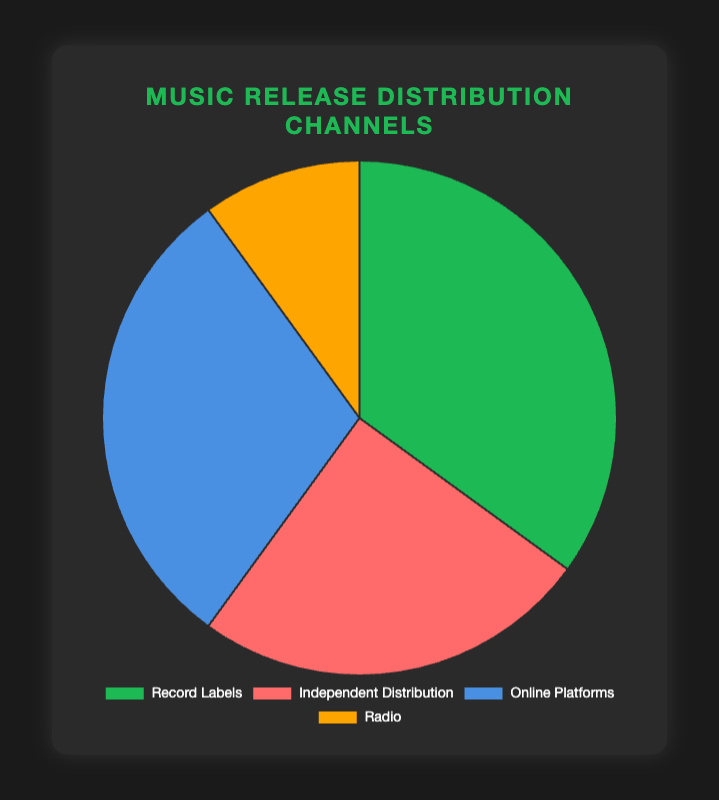Which distribution channel has the largest share of music releases? The pie chart shows the distribution channels for music releases and their corresponding percentages. The largest slice represents Record Labels with 35%.
Answer: Record Labels What is the combined percentage of music releases through Record Labels and Online Platforms? In the pie chart, Record Labels have 35% and Online Platforms have 30%. Adding these percentages together: 35% + 30% = 65%.
Answer: 65% How does the share of Independent Distribution compare to that of Radio? The pie chart shows Independent Distribution at 25% and Radio at 10%. Independent Distribution is greater by 15% (25% - 10%).
Answer: Independent Distribution is 15% greater What is the difference between the highest and lowest percentage distribution channels? The chart shows the highest percentage is for Record Labels (35%) and the lowest is for Radio (10%). The difference is 35% - 10% = 25%.
Answer: 25% What percentage of music releases are not distributed through Radio? The pie chart shows that 10% of music releases are through Radio. Therefore, 100% - 10% = 90% are not distributed through Radio.
Answer: 90% Which channel is represented by the green color in the pie chart? The green color in the pie chart corresponds to Record Labels, which has a percentage of 35%.
Answer: Record Labels If the percentages for Record Labels and Online Platforms were equal, what would be the new combined percentage for these two channels? Currently, Record Labels have 35% and Online Platforms have 30%. If both were equal, 32.5% each, the combined percentage would be 32.5% + 32.5% = 65%.
Answer: 65% Is the share of music releases through Online Platforms larger than through Independent Distribution? According to the pie chart, Online Platforms have a 30% share, while Independent Distribution has 25%. Since 30% > 25%, the share of Online Platforms is larger.
Answer: Yes What is the average percentage of all the distribution channels for music releases in the pie chart? The pie chart has four channels: Record Labels (35%), Independent Distribution (25%), Online Platforms (30%), and Radio (10%). The average is calculated as (35 + 25 + 30 + 10) / 4 = 25%.
Answer: 25% How much more significant is the share of Record Labels compared to the average percentage of music release distribution across all channels? The average percentage across all channels is 25%. The share of Record Labels is 35%. The difference is 35% - 25% = 10%.
Answer: 10% more 